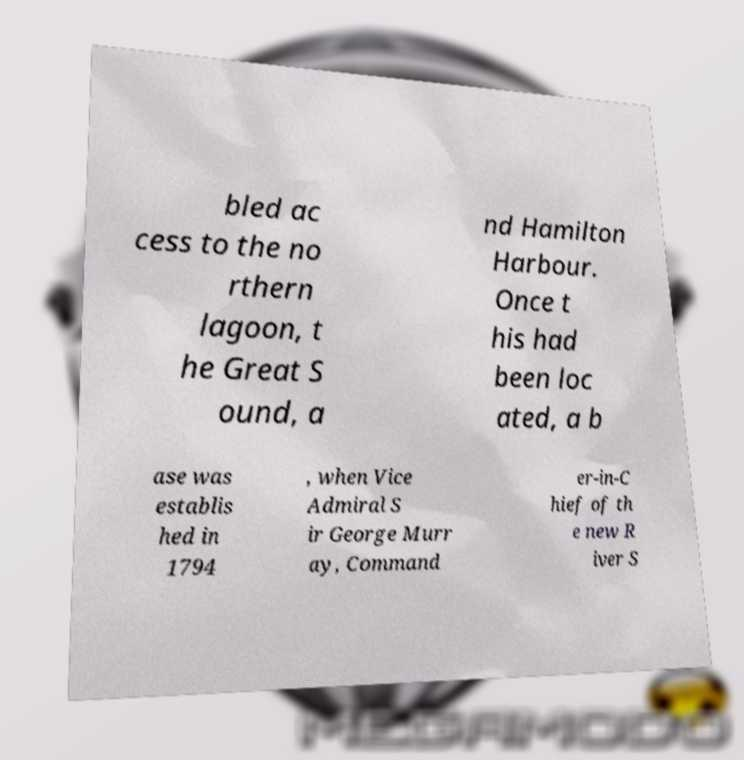There's text embedded in this image that I need extracted. Can you transcribe it verbatim? bled ac cess to the no rthern lagoon, t he Great S ound, a nd Hamilton Harbour. Once t his had been loc ated, a b ase was establis hed in 1794 , when Vice Admiral S ir George Murr ay, Command er-in-C hief of th e new R iver S 